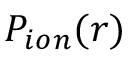Convert formula to latex. <formula><loc_0><loc_0><loc_500><loc_500>P _ { i o n } ( r )</formula> 